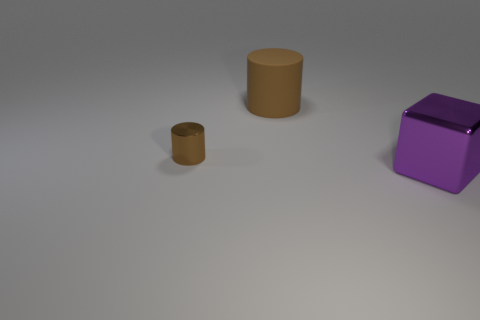Is there anything else that is the same size as the metal cylinder?
Your answer should be very brief. No. Are there any other things that are made of the same material as the big brown object?
Your response must be concise. No. Does the purple object have the same size as the cylinder right of the small brown metal thing?
Make the answer very short. Yes. Are there any tiny brown objects?
Provide a succinct answer. Yes. What is the material of the other object that is the same shape as the small brown metallic object?
Provide a succinct answer. Rubber. How big is the metal object right of the large object on the left side of the shiny thing on the right side of the small shiny thing?
Your answer should be compact. Large. Are there any metal blocks on the right side of the large cube?
Your response must be concise. No. What size is the thing that is the same material as the large purple cube?
Provide a short and direct response. Small. What number of big brown matte things have the same shape as the tiny thing?
Your answer should be very brief. 1. Does the small thing have the same material as the big object on the right side of the brown rubber thing?
Give a very brief answer. Yes. 